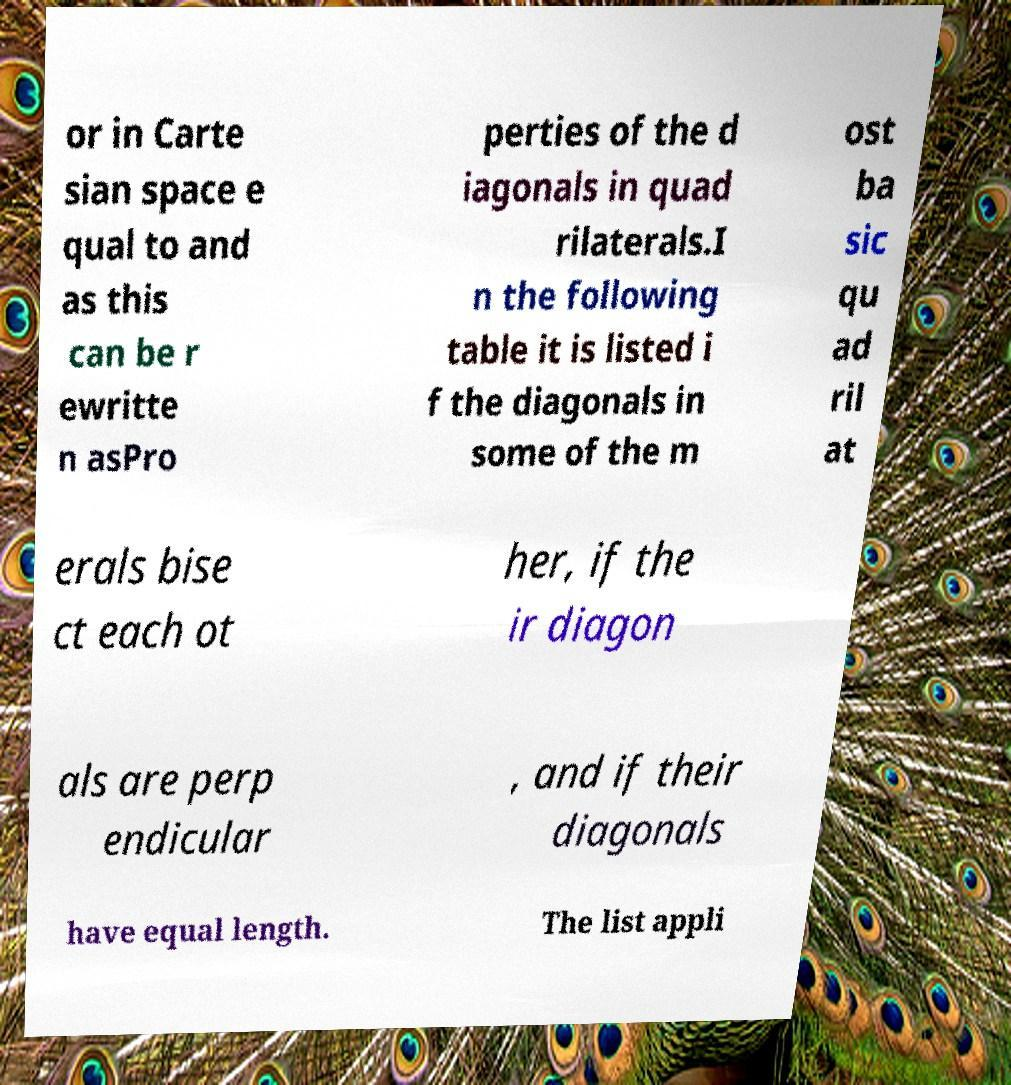Can you accurately transcribe the text from the provided image for me? or in Carte sian space e qual to and as this can be r ewritte n asPro perties of the d iagonals in quad rilaterals.I n the following table it is listed i f the diagonals in some of the m ost ba sic qu ad ril at erals bise ct each ot her, if the ir diagon als are perp endicular , and if their diagonals have equal length. The list appli 